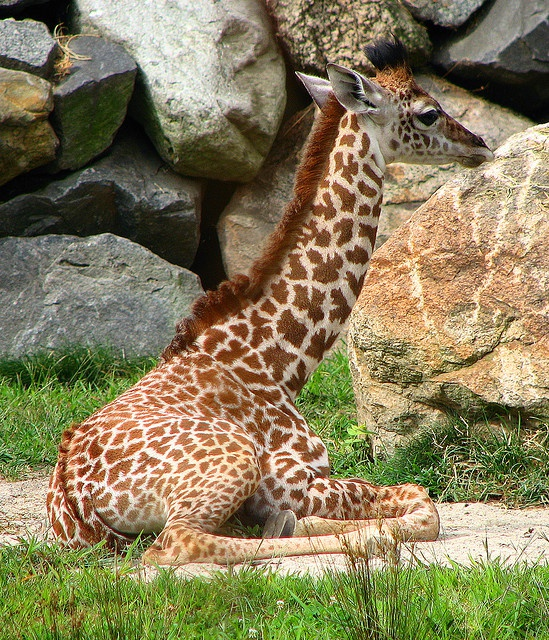Describe the objects in this image and their specific colors. I can see a giraffe in gray, maroon, ivory, and brown tones in this image. 